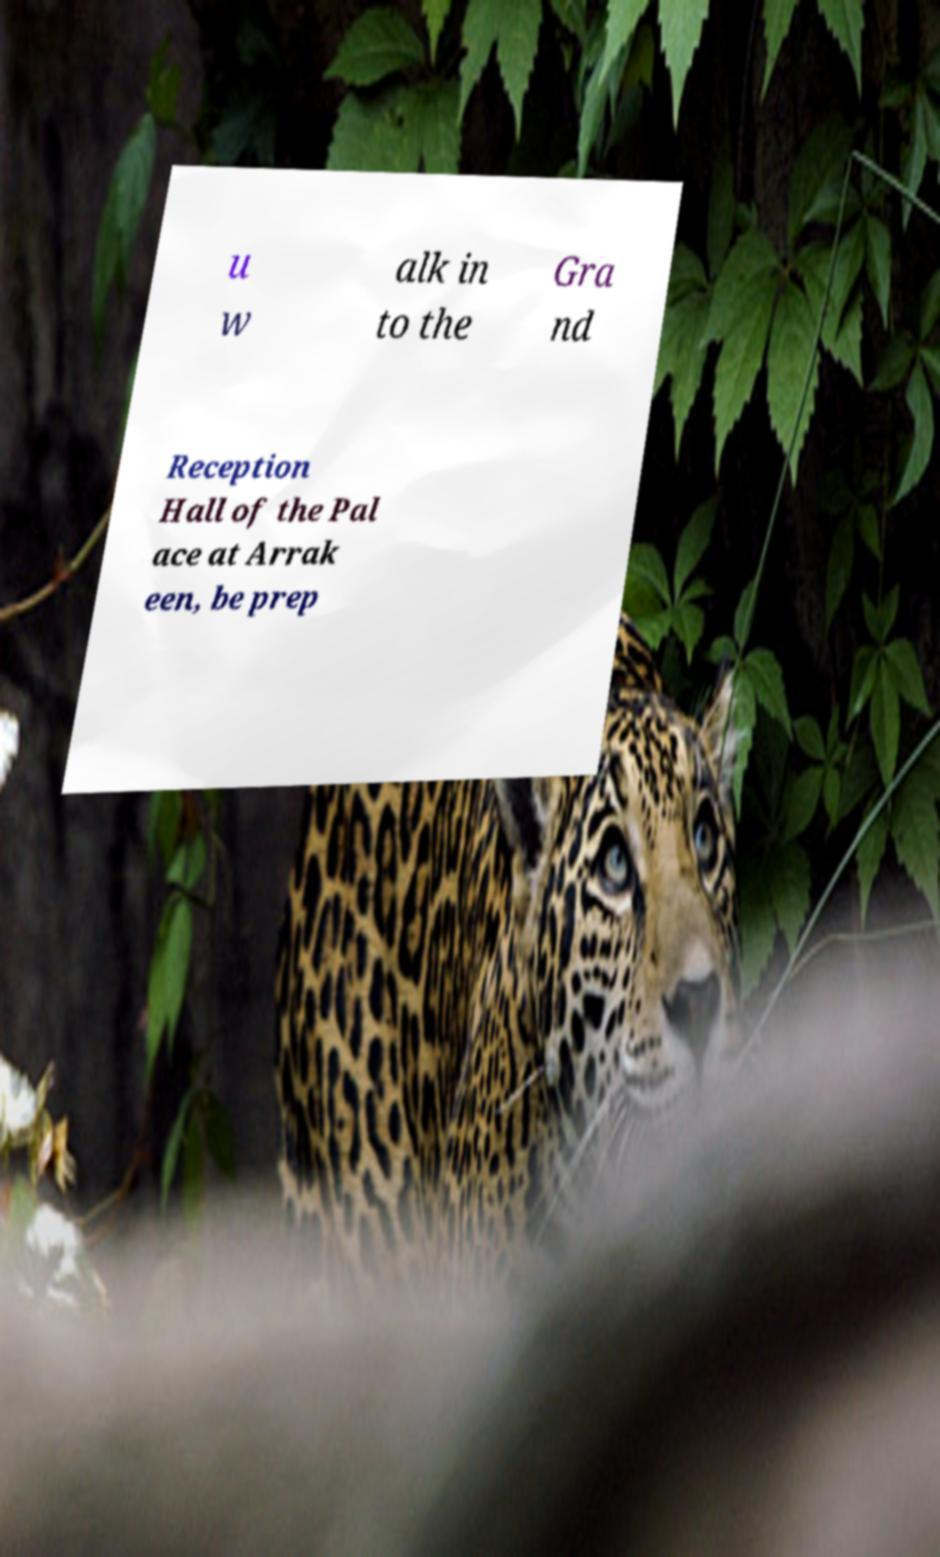Please read and relay the text visible in this image. What does it say? u w alk in to the Gra nd Reception Hall of the Pal ace at Arrak een, be prep 